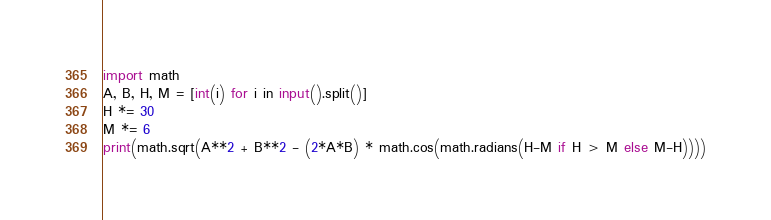<code> <loc_0><loc_0><loc_500><loc_500><_Python_>import math
A, B, H, M = [int(i) for i in input().split()]
H *= 30
M *= 6
print(math.sqrt(A**2 + B**2 - (2*A*B) * math.cos(math.radians(H-M if H > M else M-H))))</code> 